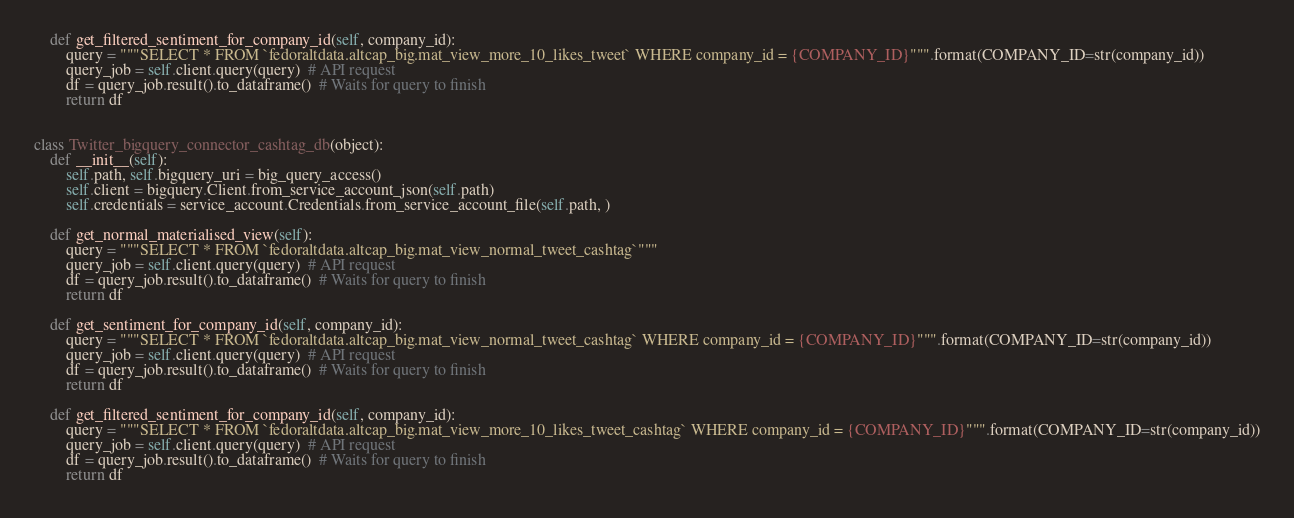Convert code to text. <code><loc_0><loc_0><loc_500><loc_500><_Python_>    def get_filtered_sentiment_for_company_id(self, company_id):
        query = """SELECT * FROM `fedoraltdata.altcap_big.mat_view_more_10_likes_tweet` WHERE company_id = {COMPANY_ID}""".format(COMPANY_ID=str(company_id))
        query_job = self.client.query(query)  # API request
        df = query_job.result().to_dataframe()  # Waits for query to finish
        return df


class Twitter_bigquery_connector_cashtag_db(object):
    def __init__(self):
        self.path, self.bigquery_uri = big_query_access()
        self.client = bigquery.Client.from_service_account_json(self.path)
        self.credentials = service_account.Credentials.from_service_account_file(self.path, )

    def get_normal_materialised_view(self):
        query = """SELECT * FROM `fedoraltdata.altcap_big.mat_view_normal_tweet_cashtag`"""
        query_job = self.client.query(query)  # API request
        df = query_job.result().to_dataframe()  # Waits for query to finish
        return df

    def get_sentiment_for_company_id(self, company_id):
        query = """SELECT * FROM `fedoraltdata.altcap_big.mat_view_normal_tweet_cashtag` WHERE company_id = {COMPANY_ID}""".format(COMPANY_ID=str(company_id))
        query_job = self.client.query(query)  # API request
        df = query_job.result().to_dataframe()  # Waits for query to finish
        return df

    def get_filtered_sentiment_for_company_id(self, company_id):
        query = """SELECT * FROM `fedoraltdata.altcap_big.mat_view_more_10_likes_tweet_cashtag` WHERE company_id = {COMPANY_ID}""".format(COMPANY_ID=str(company_id))
        query_job = self.client.query(query)  # API request
        df = query_job.result().to_dataframe()  # Waits for query to finish
        return df
</code> 